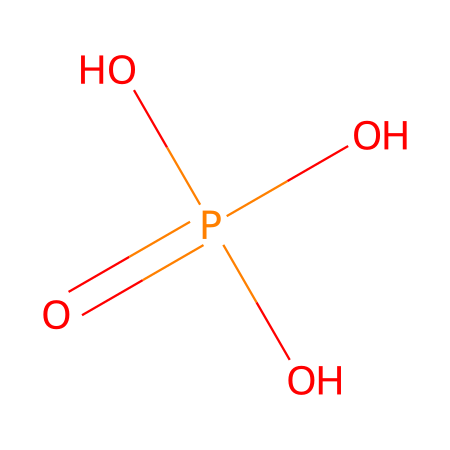What is the name of this chemical? The SMILES representation corresponds to a chemical with the formula that consists of phosphorus and oxygen atoms, which is known as phosphoric acid.
Answer: phosphoric acid How many oxygen atoms are present in this molecule? The SMILES notation shows four oxygen atoms connected to the phosphorus atom through one double bond and three single bonds, indicating the presence of four oxygen atoms.
Answer: four What is the oxidation state of phosphorus in this compound? In phosphoric acid (O=P(O)(O)O), phosphorus is bonded to four oxygen atoms. The typical oxidation state for phosphorus with these bonds is +5.
Answer: +5 What type of acid is phosphoric acid classified as? Phosphoric acid is classified as a triprotic acid because it can donate three protons (H+) in an aqueous solution. The presence of three hydroxyl groups (-OH) linked to phosphorus facilitates this.
Answer: triprotic What is the effect of phosphoric acid on pH levels in wine? Phosphoric acid, when added to wine, lowers the pH by increasing the acidity. This adjustment is essential for enhancing flavor and stability.
Answer: lowers pH What structural feature in this molecule contributes to its acidic properties? The presence of the three hydroxyl (–OH) groups contributes to its acidic properties as they can dissociate, releasing protons (H+) into the solution, which defines acidity.
Answer: hydroxyl groups Is phosphoric acid a strong or weak acid? Phosphoric acid is considered a weak acid since it does not completely dissociate in solution compared to strong acids like hydrochloric acid.
Answer: weak acid 